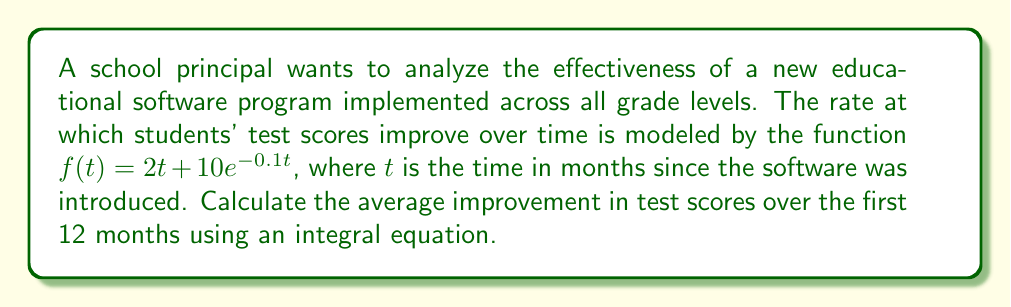Provide a solution to this math problem. To solve this problem, we'll follow these steps:

1) The average improvement over a time period is given by the definite integral of the rate function divided by the length of the time period. In this case, we need to calculate:

   $$\text{Average Improvement} = \frac{1}{12} \int_0^{12} f(t) dt$$

2) Substitute the given function into the integral:

   $$\frac{1}{12} \int_0^{12} (2t + 10e^{-0.1t}) dt$$

3) Split the integral:

   $$\frac{1}{12} \left[\int_0^{12} 2t dt + \int_0^{12} 10e^{-0.1t} dt\right]$$

4) Evaluate the first integral:

   $$\int_0^{12} 2t dt = t^2 \Big|_0^{12} = 144 - 0 = 144$$

5) Evaluate the second integral:

   $$\int_0^{12} 10e^{-0.1t} dt = -100e^{-0.1t} \Big|_0^{12} = -100(e^{-1.2} - 1) \approx 69.88$$

6) Sum the results:

   $$\frac{1}{12}(144 + 69.88) \approx 17.82$$

Therefore, the average improvement in test scores over the first 12 months is approximately 17.82 points.
Answer: 17.82 points 